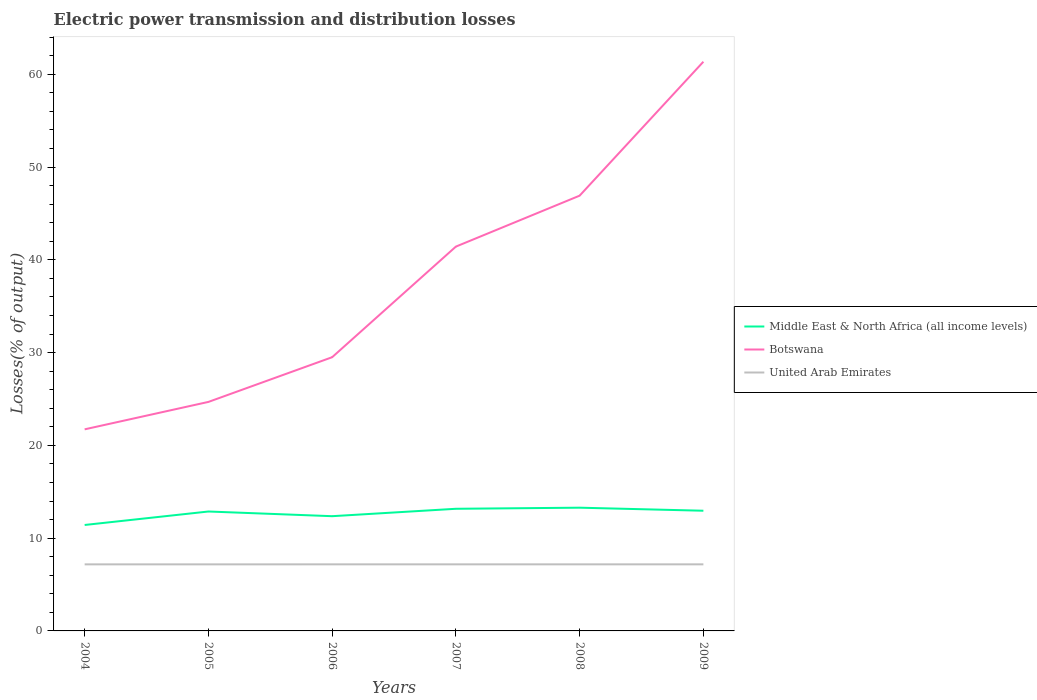Is the number of lines equal to the number of legend labels?
Provide a short and direct response. Yes. Across all years, what is the maximum electric power transmission and distribution losses in Botswana?
Offer a very short reply. 21.73. In which year was the electric power transmission and distribution losses in Botswana maximum?
Offer a very short reply. 2004. What is the total electric power transmission and distribution losses in United Arab Emirates in the graph?
Make the answer very short. -0. What is the difference between the highest and the second highest electric power transmission and distribution losses in Middle East & North Africa (all income levels)?
Offer a terse response. 1.86. How many lines are there?
Make the answer very short. 3. How many years are there in the graph?
Your answer should be very brief. 6. What is the difference between two consecutive major ticks on the Y-axis?
Provide a succinct answer. 10. Where does the legend appear in the graph?
Provide a succinct answer. Center right. How are the legend labels stacked?
Make the answer very short. Vertical. What is the title of the graph?
Offer a terse response. Electric power transmission and distribution losses. What is the label or title of the X-axis?
Your answer should be very brief. Years. What is the label or title of the Y-axis?
Offer a very short reply. Losses(% of output). What is the Losses(% of output) in Middle East & North Africa (all income levels) in 2004?
Keep it short and to the point. 11.42. What is the Losses(% of output) of Botswana in 2004?
Offer a very short reply. 21.73. What is the Losses(% of output) in United Arab Emirates in 2004?
Give a very brief answer. 7.18. What is the Losses(% of output) of Middle East & North Africa (all income levels) in 2005?
Offer a very short reply. 12.87. What is the Losses(% of output) of Botswana in 2005?
Your answer should be compact. 24.68. What is the Losses(% of output) of United Arab Emirates in 2005?
Your answer should be very brief. 7.17. What is the Losses(% of output) in Middle East & North Africa (all income levels) in 2006?
Offer a very short reply. 12.37. What is the Losses(% of output) of Botswana in 2006?
Ensure brevity in your answer.  29.5. What is the Losses(% of output) of United Arab Emirates in 2006?
Your answer should be very brief. 7.18. What is the Losses(% of output) of Middle East & North Africa (all income levels) in 2007?
Your answer should be compact. 13.16. What is the Losses(% of output) in Botswana in 2007?
Provide a short and direct response. 41.43. What is the Losses(% of output) in United Arab Emirates in 2007?
Provide a succinct answer. 7.18. What is the Losses(% of output) in Middle East & North Africa (all income levels) in 2008?
Keep it short and to the point. 13.28. What is the Losses(% of output) of Botswana in 2008?
Your answer should be compact. 46.92. What is the Losses(% of output) of United Arab Emirates in 2008?
Provide a succinct answer. 7.18. What is the Losses(% of output) of Middle East & North Africa (all income levels) in 2009?
Provide a short and direct response. 12.95. What is the Losses(% of output) of Botswana in 2009?
Provide a succinct answer. 61.35. What is the Losses(% of output) in United Arab Emirates in 2009?
Your answer should be compact. 7.18. Across all years, what is the maximum Losses(% of output) of Middle East & North Africa (all income levels)?
Provide a succinct answer. 13.28. Across all years, what is the maximum Losses(% of output) in Botswana?
Give a very brief answer. 61.35. Across all years, what is the maximum Losses(% of output) of United Arab Emirates?
Offer a terse response. 7.18. Across all years, what is the minimum Losses(% of output) in Middle East & North Africa (all income levels)?
Your answer should be compact. 11.42. Across all years, what is the minimum Losses(% of output) of Botswana?
Your answer should be very brief. 21.73. Across all years, what is the minimum Losses(% of output) in United Arab Emirates?
Provide a succinct answer. 7.17. What is the total Losses(% of output) in Middle East & North Africa (all income levels) in the graph?
Your response must be concise. 76.06. What is the total Losses(% of output) of Botswana in the graph?
Your answer should be compact. 225.61. What is the total Losses(% of output) in United Arab Emirates in the graph?
Offer a terse response. 43.05. What is the difference between the Losses(% of output) of Middle East & North Africa (all income levels) in 2004 and that in 2005?
Your answer should be compact. -1.45. What is the difference between the Losses(% of output) of Botswana in 2004 and that in 2005?
Your answer should be compact. -2.95. What is the difference between the Losses(% of output) in Middle East & North Africa (all income levels) in 2004 and that in 2006?
Offer a terse response. -0.95. What is the difference between the Losses(% of output) of Botswana in 2004 and that in 2006?
Your response must be concise. -7.77. What is the difference between the Losses(% of output) in United Arab Emirates in 2004 and that in 2006?
Your answer should be compact. -0. What is the difference between the Losses(% of output) in Middle East & North Africa (all income levels) in 2004 and that in 2007?
Offer a very short reply. -1.75. What is the difference between the Losses(% of output) in Botswana in 2004 and that in 2007?
Offer a very short reply. -19.7. What is the difference between the Losses(% of output) in United Arab Emirates in 2004 and that in 2007?
Your response must be concise. -0. What is the difference between the Losses(% of output) in Middle East & North Africa (all income levels) in 2004 and that in 2008?
Make the answer very short. -1.86. What is the difference between the Losses(% of output) in Botswana in 2004 and that in 2008?
Your answer should be very brief. -25.19. What is the difference between the Losses(% of output) of United Arab Emirates in 2004 and that in 2008?
Your answer should be very brief. -0. What is the difference between the Losses(% of output) in Middle East & North Africa (all income levels) in 2004 and that in 2009?
Give a very brief answer. -1.54. What is the difference between the Losses(% of output) in Botswana in 2004 and that in 2009?
Your answer should be compact. -39.62. What is the difference between the Losses(% of output) of United Arab Emirates in 2004 and that in 2009?
Make the answer very short. -0. What is the difference between the Losses(% of output) of Middle East & North Africa (all income levels) in 2005 and that in 2006?
Provide a succinct answer. 0.5. What is the difference between the Losses(% of output) of Botswana in 2005 and that in 2006?
Keep it short and to the point. -4.82. What is the difference between the Losses(% of output) of United Arab Emirates in 2005 and that in 2006?
Make the answer very short. -0. What is the difference between the Losses(% of output) of Middle East & North Africa (all income levels) in 2005 and that in 2007?
Your response must be concise. -0.29. What is the difference between the Losses(% of output) in Botswana in 2005 and that in 2007?
Give a very brief answer. -16.74. What is the difference between the Losses(% of output) of United Arab Emirates in 2005 and that in 2007?
Ensure brevity in your answer.  -0. What is the difference between the Losses(% of output) in Middle East & North Africa (all income levels) in 2005 and that in 2008?
Give a very brief answer. -0.41. What is the difference between the Losses(% of output) of Botswana in 2005 and that in 2008?
Give a very brief answer. -22.23. What is the difference between the Losses(% of output) in United Arab Emirates in 2005 and that in 2008?
Keep it short and to the point. -0. What is the difference between the Losses(% of output) in Middle East & North Africa (all income levels) in 2005 and that in 2009?
Offer a very short reply. -0.08. What is the difference between the Losses(% of output) of Botswana in 2005 and that in 2009?
Make the answer very short. -36.67. What is the difference between the Losses(% of output) of United Arab Emirates in 2005 and that in 2009?
Your answer should be very brief. -0. What is the difference between the Losses(% of output) of Middle East & North Africa (all income levels) in 2006 and that in 2007?
Provide a succinct answer. -0.8. What is the difference between the Losses(% of output) of Botswana in 2006 and that in 2007?
Offer a very short reply. -11.92. What is the difference between the Losses(% of output) in Middle East & North Africa (all income levels) in 2006 and that in 2008?
Offer a terse response. -0.92. What is the difference between the Losses(% of output) in Botswana in 2006 and that in 2008?
Offer a terse response. -17.41. What is the difference between the Losses(% of output) in United Arab Emirates in 2006 and that in 2008?
Make the answer very short. -0. What is the difference between the Losses(% of output) in Middle East & North Africa (all income levels) in 2006 and that in 2009?
Your answer should be very brief. -0.59. What is the difference between the Losses(% of output) of Botswana in 2006 and that in 2009?
Offer a terse response. -31.85. What is the difference between the Losses(% of output) of United Arab Emirates in 2006 and that in 2009?
Provide a short and direct response. -0. What is the difference between the Losses(% of output) of Middle East & North Africa (all income levels) in 2007 and that in 2008?
Offer a terse response. -0.12. What is the difference between the Losses(% of output) of Botswana in 2007 and that in 2008?
Offer a terse response. -5.49. What is the difference between the Losses(% of output) of United Arab Emirates in 2007 and that in 2008?
Provide a succinct answer. -0. What is the difference between the Losses(% of output) of Middle East & North Africa (all income levels) in 2007 and that in 2009?
Keep it short and to the point. 0.21. What is the difference between the Losses(% of output) of Botswana in 2007 and that in 2009?
Make the answer very short. -19.93. What is the difference between the Losses(% of output) of United Arab Emirates in 2007 and that in 2009?
Offer a very short reply. -0. What is the difference between the Losses(% of output) of Middle East & North Africa (all income levels) in 2008 and that in 2009?
Offer a terse response. 0.33. What is the difference between the Losses(% of output) of Botswana in 2008 and that in 2009?
Provide a succinct answer. -14.44. What is the difference between the Losses(% of output) of United Arab Emirates in 2008 and that in 2009?
Ensure brevity in your answer.  -0. What is the difference between the Losses(% of output) of Middle East & North Africa (all income levels) in 2004 and the Losses(% of output) of Botswana in 2005?
Your response must be concise. -13.26. What is the difference between the Losses(% of output) of Middle East & North Africa (all income levels) in 2004 and the Losses(% of output) of United Arab Emirates in 2005?
Offer a very short reply. 4.24. What is the difference between the Losses(% of output) in Botswana in 2004 and the Losses(% of output) in United Arab Emirates in 2005?
Give a very brief answer. 14.55. What is the difference between the Losses(% of output) in Middle East & North Africa (all income levels) in 2004 and the Losses(% of output) in Botswana in 2006?
Make the answer very short. -18.08. What is the difference between the Losses(% of output) in Middle East & North Africa (all income levels) in 2004 and the Losses(% of output) in United Arab Emirates in 2006?
Offer a terse response. 4.24. What is the difference between the Losses(% of output) in Botswana in 2004 and the Losses(% of output) in United Arab Emirates in 2006?
Provide a succinct answer. 14.55. What is the difference between the Losses(% of output) in Middle East & North Africa (all income levels) in 2004 and the Losses(% of output) in Botswana in 2007?
Keep it short and to the point. -30.01. What is the difference between the Losses(% of output) in Middle East & North Africa (all income levels) in 2004 and the Losses(% of output) in United Arab Emirates in 2007?
Keep it short and to the point. 4.24. What is the difference between the Losses(% of output) of Botswana in 2004 and the Losses(% of output) of United Arab Emirates in 2007?
Your answer should be compact. 14.55. What is the difference between the Losses(% of output) in Middle East & North Africa (all income levels) in 2004 and the Losses(% of output) in Botswana in 2008?
Ensure brevity in your answer.  -35.5. What is the difference between the Losses(% of output) of Middle East & North Africa (all income levels) in 2004 and the Losses(% of output) of United Arab Emirates in 2008?
Your answer should be compact. 4.24. What is the difference between the Losses(% of output) in Botswana in 2004 and the Losses(% of output) in United Arab Emirates in 2008?
Offer a terse response. 14.55. What is the difference between the Losses(% of output) in Middle East & North Africa (all income levels) in 2004 and the Losses(% of output) in Botswana in 2009?
Provide a succinct answer. -49.93. What is the difference between the Losses(% of output) of Middle East & North Africa (all income levels) in 2004 and the Losses(% of output) of United Arab Emirates in 2009?
Ensure brevity in your answer.  4.24. What is the difference between the Losses(% of output) of Botswana in 2004 and the Losses(% of output) of United Arab Emirates in 2009?
Offer a terse response. 14.55. What is the difference between the Losses(% of output) of Middle East & North Africa (all income levels) in 2005 and the Losses(% of output) of Botswana in 2006?
Your response must be concise. -16.63. What is the difference between the Losses(% of output) of Middle East & North Africa (all income levels) in 2005 and the Losses(% of output) of United Arab Emirates in 2006?
Your response must be concise. 5.7. What is the difference between the Losses(% of output) of Botswana in 2005 and the Losses(% of output) of United Arab Emirates in 2006?
Offer a very short reply. 17.51. What is the difference between the Losses(% of output) of Middle East & North Africa (all income levels) in 2005 and the Losses(% of output) of Botswana in 2007?
Offer a terse response. -28.55. What is the difference between the Losses(% of output) of Middle East & North Africa (all income levels) in 2005 and the Losses(% of output) of United Arab Emirates in 2007?
Keep it short and to the point. 5.7. What is the difference between the Losses(% of output) of Botswana in 2005 and the Losses(% of output) of United Arab Emirates in 2007?
Your response must be concise. 17.51. What is the difference between the Losses(% of output) of Middle East & North Africa (all income levels) in 2005 and the Losses(% of output) of Botswana in 2008?
Your answer should be compact. -34.04. What is the difference between the Losses(% of output) of Middle East & North Africa (all income levels) in 2005 and the Losses(% of output) of United Arab Emirates in 2008?
Provide a short and direct response. 5.7. What is the difference between the Losses(% of output) in Botswana in 2005 and the Losses(% of output) in United Arab Emirates in 2008?
Offer a very short reply. 17.51. What is the difference between the Losses(% of output) of Middle East & North Africa (all income levels) in 2005 and the Losses(% of output) of Botswana in 2009?
Keep it short and to the point. -48.48. What is the difference between the Losses(% of output) of Middle East & North Africa (all income levels) in 2005 and the Losses(% of output) of United Arab Emirates in 2009?
Make the answer very short. 5.7. What is the difference between the Losses(% of output) in Botswana in 2005 and the Losses(% of output) in United Arab Emirates in 2009?
Make the answer very short. 17.51. What is the difference between the Losses(% of output) in Middle East & North Africa (all income levels) in 2006 and the Losses(% of output) in Botswana in 2007?
Offer a very short reply. -29.06. What is the difference between the Losses(% of output) in Middle East & North Africa (all income levels) in 2006 and the Losses(% of output) in United Arab Emirates in 2007?
Offer a terse response. 5.19. What is the difference between the Losses(% of output) in Botswana in 2006 and the Losses(% of output) in United Arab Emirates in 2007?
Offer a very short reply. 22.33. What is the difference between the Losses(% of output) in Middle East & North Africa (all income levels) in 2006 and the Losses(% of output) in Botswana in 2008?
Provide a succinct answer. -34.55. What is the difference between the Losses(% of output) in Middle East & North Africa (all income levels) in 2006 and the Losses(% of output) in United Arab Emirates in 2008?
Keep it short and to the point. 5.19. What is the difference between the Losses(% of output) of Botswana in 2006 and the Losses(% of output) of United Arab Emirates in 2008?
Offer a very short reply. 22.33. What is the difference between the Losses(% of output) of Middle East & North Africa (all income levels) in 2006 and the Losses(% of output) of Botswana in 2009?
Offer a terse response. -48.99. What is the difference between the Losses(% of output) of Middle East & North Africa (all income levels) in 2006 and the Losses(% of output) of United Arab Emirates in 2009?
Offer a very short reply. 5.19. What is the difference between the Losses(% of output) in Botswana in 2006 and the Losses(% of output) in United Arab Emirates in 2009?
Provide a succinct answer. 22.32. What is the difference between the Losses(% of output) in Middle East & North Africa (all income levels) in 2007 and the Losses(% of output) in Botswana in 2008?
Your answer should be compact. -33.75. What is the difference between the Losses(% of output) in Middle East & North Africa (all income levels) in 2007 and the Losses(% of output) in United Arab Emirates in 2008?
Provide a succinct answer. 5.99. What is the difference between the Losses(% of output) of Botswana in 2007 and the Losses(% of output) of United Arab Emirates in 2008?
Keep it short and to the point. 34.25. What is the difference between the Losses(% of output) in Middle East & North Africa (all income levels) in 2007 and the Losses(% of output) in Botswana in 2009?
Your response must be concise. -48.19. What is the difference between the Losses(% of output) in Middle East & North Africa (all income levels) in 2007 and the Losses(% of output) in United Arab Emirates in 2009?
Provide a succinct answer. 5.99. What is the difference between the Losses(% of output) of Botswana in 2007 and the Losses(% of output) of United Arab Emirates in 2009?
Offer a terse response. 34.25. What is the difference between the Losses(% of output) of Middle East & North Africa (all income levels) in 2008 and the Losses(% of output) of Botswana in 2009?
Your answer should be very brief. -48.07. What is the difference between the Losses(% of output) of Middle East & North Africa (all income levels) in 2008 and the Losses(% of output) of United Arab Emirates in 2009?
Your answer should be compact. 6.11. What is the difference between the Losses(% of output) in Botswana in 2008 and the Losses(% of output) in United Arab Emirates in 2009?
Make the answer very short. 39.74. What is the average Losses(% of output) of Middle East & North Africa (all income levels) per year?
Provide a short and direct response. 12.68. What is the average Losses(% of output) in Botswana per year?
Your response must be concise. 37.6. What is the average Losses(% of output) in United Arab Emirates per year?
Your response must be concise. 7.18. In the year 2004, what is the difference between the Losses(% of output) in Middle East & North Africa (all income levels) and Losses(% of output) in Botswana?
Give a very brief answer. -10.31. In the year 2004, what is the difference between the Losses(% of output) of Middle East & North Africa (all income levels) and Losses(% of output) of United Arab Emirates?
Make the answer very short. 4.24. In the year 2004, what is the difference between the Losses(% of output) of Botswana and Losses(% of output) of United Arab Emirates?
Provide a short and direct response. 14.55. In the year 2005, what is the difference between the Losses(% of output) in Middle East & North Africa (all income levels) and Losses(% of output) in Botswana?
Make the answer very short. -11.81. In the year 2005, what is the difference between the Losses(% of output) in Middle East & North Africa (all income levels) and Losses(% of output) in United Arab Emirates?
Offer a very short reply. 5.7. In the year 2005, what is the difference between the Losses(% of output) of Botswana and Losses(% of output) of United Arab Emirates?
Provide a succinct answer. 17.51. In the year 2006, what is the difference between the Losses(% of output) of Middle East & North Africa (all income levels) and Losses(% of output) of Botswana?
Your answer should be compact. -17.13. In the year 2006, what is the difference between the Losses(% of output) in Middle East & North Africa (all income levels) and Losses(% of output) in United Arab Emirates?
Give a very brief answer. 5.19. In the year 2006, what is the difference between the Losses(% of output) of Botswana and Losses(% of output) of United Arab Emirates?
Your response must be concise. 22.33. In the year 2007, what is the difference between the Losses(% of output) in Middle East & North Africa (all income levels) and Losses(% of output) in Botswana?
Provide a short and direct response. -28.26. In the year 2007, what is the difference between the Losses(% of output) of Middle East & North Africa (all income levels) and Losses(% of output) of United Arab Emirates?
Offer a terse response. 5.99. In the year 2007, what is the difference between the Losses(% of output) of Botswana and Losses(% of output) of United Arab Emirates?
Your response must be concise. 34.25. In the year 2008, what is the difference between the Losses(% of output) in Middle East & North Africa (all income levels) and Losses(% of output) in Botswana?
Ensure brevity in your answer.  -33.63. In the year 2008, what is the difference between the Losses(% of output) of Middle East & North Africa (all income levels) and Losses(% of output) of United Arab Emirates?
Offer a terse response. 6.11. In the year 2008, what is the difference between the Losses(% of output) of Botswana and Losses(% of output) of United Arab Emirates?
Keep it short and to the point. 39.74. In the year 2009, what is the difference between the Losses(% of output) in Middle East & North Africa (all income levels) and Losses(% of output) in Botswana?
Give a very brief answer. -48.4. In the year 2009, what is the difference between the Losses(% of output) of Middle East & North Africa (all income levels) and Losses(% of output) of United Arab Emirates?
Ensure brevity in your answer.  5.78. In the year 2009, what is the difference between the Losses(% of output) of Botswana and Losses(% of output) of United Arab Emirates?
Your response must be concise. 54.18. What is the ratio of the Losses(% of output) of Middle East & North Africa (all income levels) in 2004 to that in 2005?
Offer a very short reply. 0.89. What is the ratio of the Losses(% of output) of Botswana in 2004 to that in 2005?
Make the answer very short. 0.88. What is the ratio of the Losses(% of output) in Middle East & North Africa (all income levels) in 2004 to that in 2006?
Provide a succinct answer. 0.92. What is the ratio of the Losses(% of output) of Botswana in 2004 to that in 2006?
Your answer should be very brief. 0.74. What is the ratio of the Losses(% of output) of Middle East & North Africa (all income levels) in 2004 to that in 2007?
Offer a very short reply. 0.87. What is the ratio of the Losses(% of output) in Botswana in 2004 to that in 2007?
Offer a terse response. 0.52. What is the ratio of the Losses(% of output) of United Arab Emirates in 2004 to that in 2007?
Provide a succinct answer. 1. What is the ratio of the Losses(% of output) in Middle East & North Africa (all income levels) in 2004 to that in 2008?
Ensure brevity in your answer.  0.86. What is the ratio of the Losses(% of output) of Botswana in 2004 to that in 2008?
Provide a succinct answer. 0.46. What is the ratio of the Losses(% of output) in Middle East & North Africa (all income levels) in 2004 to that in 2009?
Keep it short and to the point. 0.88. What is the ratio of the Losses(% of output) of Botswana in 2004 to that in 2009?
Make the answer very short. 0.35. What is the ratio of the Losses(% of output) in United Arab Emirates in 2004 to that in 2009?
Give a very brief answer. 1. What is the ratio of the Losses(% of output) in Middle East & North Africa (all income levels) in 2005 to that in 2006?
Provide a short and direct response. 1.04. What is the ratio of the Losses(% of output) of Botswana in 2005 to that in 2006?
Keep it short and to the point. 0.84. What is the ratio of the Losses(% of output) in Middle East & North Africa (all income levels) in 2005 to that in 2007?
Provide a short and direct response. 0.98. What is the ratio of the Losses(% of output) of Botswana in 2005 to that in 2007?
Provide a succinct answer. 0.6. What is the ratio of the Losses(% of output) in Middle East & North Africa (all income levels) in 2005 to that in 2008?
Offer a very short reply. 0.97. What is the ratio of the Losses(% of output) of Botswana in 2005 to that in 2008?
Provide a succinct answer. 0.53. What is the ratio of the Losses(% of output) of Middle East & North Africa (all income levels) in 2005 to that in 2009?
Give a very brief answer. 0.99. What is the ratio of the Losses(% of output) in Botswana in 2005 to that in 2009?
Offer a terse response. 0.4. What is the ratio of the Losses(% of output) of Middle East & North Africa (all income levels) in 2006 to that in 2007?
Offer a terse response. 0.94. What is the ratio of the Losses(% of output) of Botswana in 2006 to that in 2007?
Your answer should be very brief. 0.71. What is the ratio of the Losses(% of output) in Middle East & North Africa (all income levels) in 2006 to that in 2008?
Offer a terse response. 0.93. What is the ratio of the Losses(% of output) of Botswana in 2006 to that in 2008?
Provide a short and direct response. 0.63. What is the ratio of the Losses(% of output) of United Arab Emirates in 2006 to that in 2008?
Make the answer very short. 1. What is the ratio of the Losses(% of output) of Middle East & North Africa (all income levels) in 2006 to that in 2009?
Your answer should be very brief. 0.95. What is the ratio of the Losses(% of output) in Botswana in 2006 to that in 2009?
Offer a terse response. 0.48. What is the ratio of the Losses(% of output) of United Arab Emirates in 2006 to that in 2009?
Keep it short and to the point. 1. What is the ratio of the Losses(% of output) in Botswana in 2007 to that in 2008?
Make the answer very short. 0.88. What is the ratio of the Losses(% of output) of Middle East & North Africa (all income levels) in 2007 to that in 2009?
Make the answer very short. 1.02. What is the ratio of the Losses(% of output) in Botswana in 2007 to that in 2009?
Provide a short and direct response. 0.68. What is the ratio of the Losses(% of output) in United Arab Emirates in 2007 to that in 2009?
Ensure brevity in your answer.  1. What is the ratio of the Losses(% of output) in Middle East & North Africa (all income levels) in 2008 to that in 2009?
Offer a very short reply. 1.03. What is the ratio of the Losses(% of output) in Botswana in 2008 to that in 2009?
Your answer should be very brief. 0.76. What is the ratio of the Losses(% of output) in United Arab Emirates in 2008 to that in 2009?
Provide a short and direct response. 1. What is the difference between the highest and the second highest Losses(% of output) of Middle East & North Africa (all income levels)?
Your response must be concise. 0.12. What is the difference between the highest and the second highest Losses(% of output) in Botswana?
Provide a succinct answer. 14.44. What is the difference between the highest and the second highest Losses(% of output) of United Arab Emirates?
Offer a very short reply. 0. What is the difference between the highest and the lowest Losses(% of output) of Middle East & North Africa (all income levels)?
Provide a short and direct response. 1.86. What is the difference between the highest and the lowest Losses(% of output) in Botswana?
Give a very brief answer. 39.62. What is the difference between the highest and the lowest Losses(% of output) of United Arab Emirates?
Give a very brief answer. 0. 